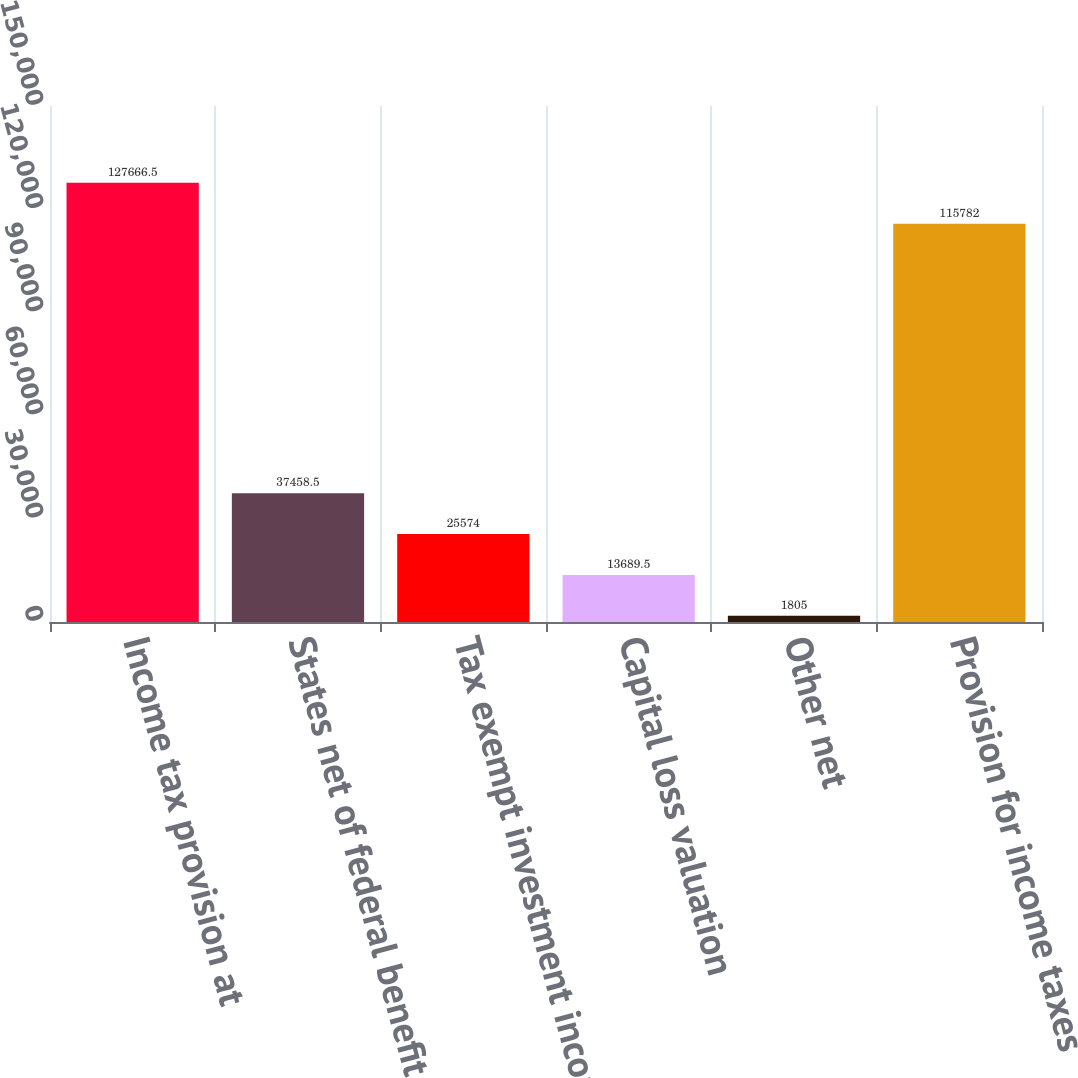Convert chart. <chart><loc_0><loc_0><loc_500><loc_500><bar_chart><fcel>Income tax provision at<fcel>States net of federal benefit<fcel>Tax exempt investment income<fcel>Capital loss valuation<fcel>Other net<fcel>Provision for income taxes<nl><fcel>127666<fcel>37458.5<fcel>25574<fcel>13689.5<fcel>1805<fcel>115782<nl></chart> 